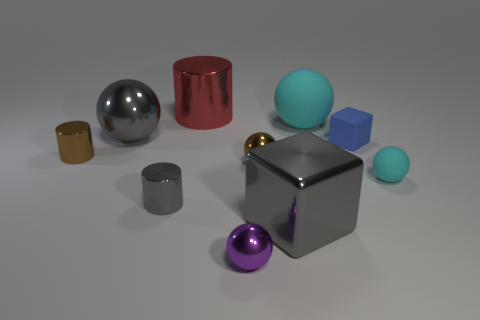Subtract all large spheres. How many spheres are left? 3 Add 2 large gray shiny things. How many large gray shiny things exist? 4 Subtract all purple spheres. How many spheres are left? 4 Subtract 0 purple cylinders. How many objects are left? 10 Subtract all cylinders. How many objects are left? 7 Subtract 3 spheres. How many spheres are left? 2 Subtract all blue cubes. Subtract all blue cylinders. How many cubes are left? 1 Subtract all cyan cylinders. How many green blocks are left? 0 Subtract all small metal objects. Subtract all brown shiny balls. How many objects are left? 5 Add 3 big cyan matte objects. How many big cyan matte objects are left? 4 